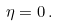<formula> <loc_0><loc_0><loc_500><loc_500>\eta = 0 \, .</formula> 